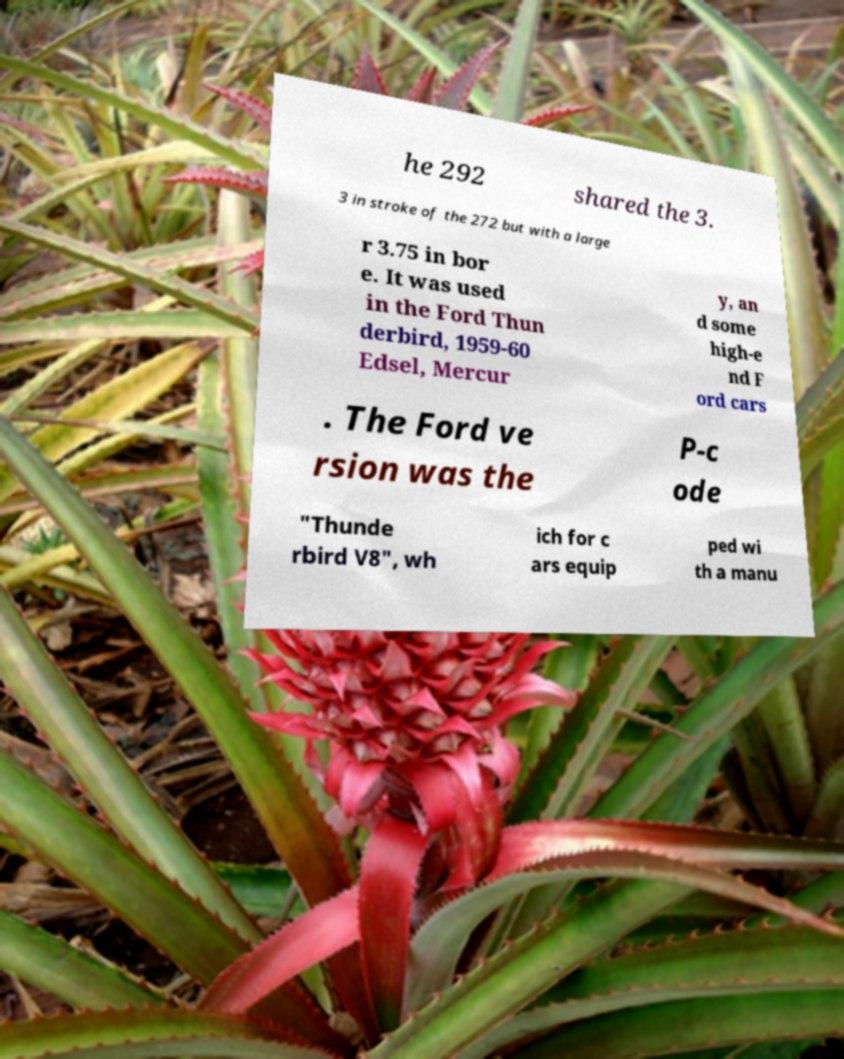Can you read and provide the text displayed in the image?This photo seems to have some interesting text. Can you extract and type it out for me? he 292 shared the 3. 3 in stroke of the 272 but with a large r 3.75 in bor e. It was used in the Ford Thun derbird, 1959-60 Edsel, Mercur y, an d some high-e nd F ord cars . The Ford ve rsion was the P-c ode "Thunde rbird V8", wh ich for c ars equip ped wi th a manu 